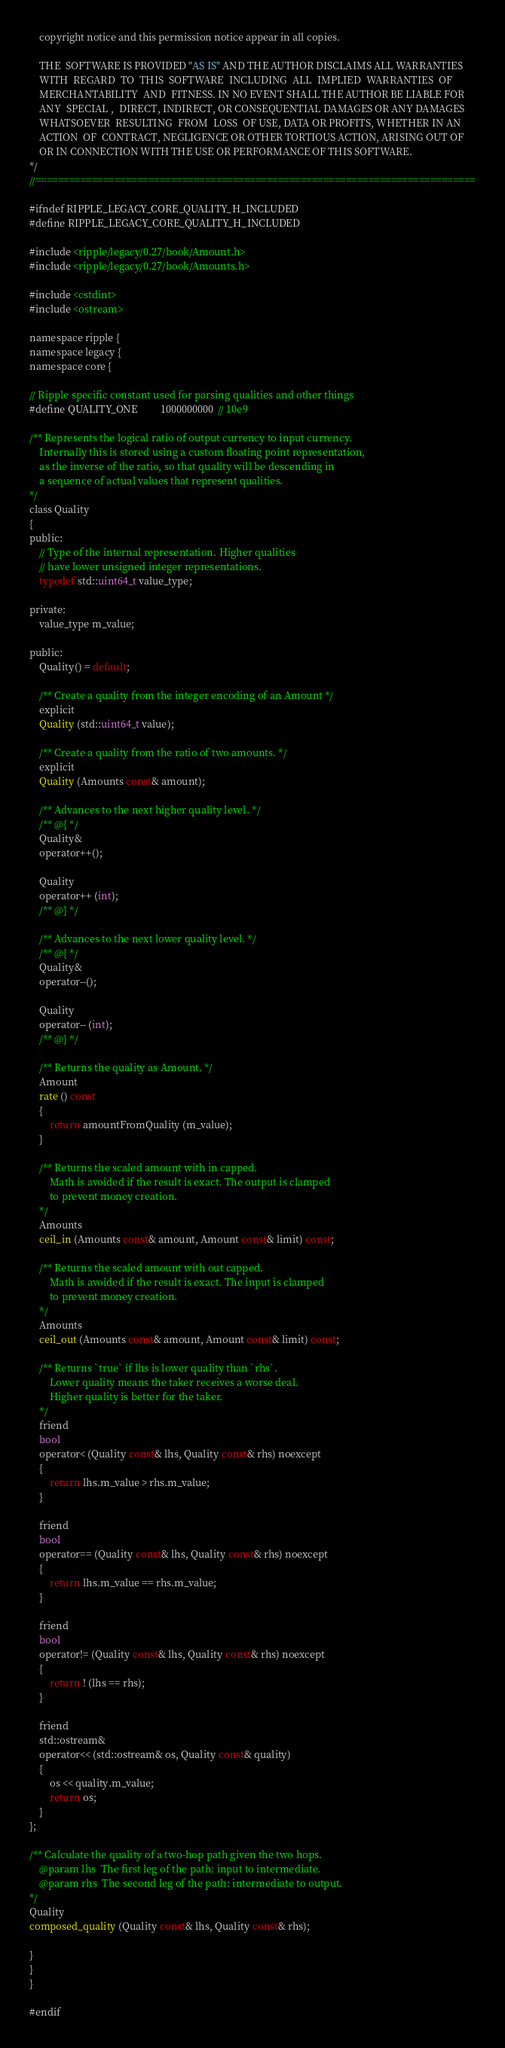Convert code to text. <code><loc_0><loc_0><loc_500><loc_500><_C_>    copyright notice and this permission notice appear in all copies.

    THE  SOFTWARE IS PROVIDED "AS IS" AND THE AUTHOR DISCLAIMS ALL WARRANTIES
    WITH  REGARD  TO  THIS  SOFTWARE  INCLUDING  ALL  IMPLIED  WARRANTIES  OF
    MERCHANTABILITY  AND  FITNESS. IN NO EVENT SHALL THE AUTHOR BE LIABLE FOR
    ANY  SPECIAL ,  DIRECT, INDIRECT, OR CONSEQUENTIAL DAMAGES OR ANY DAMAGES
    WHATSOEVER  RESULTING  FROM  LOSS  OF USE, DATA OR PROFITS, WHETHER IN AN
    ACTION  OF  CONTRACT, NEGLIGENCE OR OTHER TORTIOUS ACTION, ARISING OUT OF
    OR IN CONNECTION WITH THE USE OR PERFORMANCE OF THIS SOFTWARE.
*/
//==============================================================================

#ifndef RIPPLE_LEGACY_CORE_QUALITY_H_INCLUDED
#define RIPPLE_LEGACY_CORE_QUALITY_H_INCLUDED

#include <ripple/legacy/0.27/book/Amount.h>
#include <ripple/legacy/0.27/book/Amounts.h>

#include <cstdint>
#include <ostream>

namespace ripple {
namespace legacy {
namespace core {

// Ripple specific constant used for parsing qualities and other things
#define QUALITY_ONE         1000000000  // 10e9

/** Represents the logical ratio of output currency to input currency.
    Internally this is stored using a custom floating point representation,
    as the inverse of the ratio, so that quality will be descending in
    a sequence of actual values that represent qualities.
*/
class Quality
{
public:
    // Type of the internal representation. Higher qualities
    // have lower unsigned integer representations.
    typedef std::uint64_t value_type;

private:
    value_type m_value;

public:
    Quality() = default;

    /** Create a quality from the integer encoding of an Amount */
    explicit
    Quality (std::uint64_t value);

    /** Create a quality from the ratio of two amounts. */
    explicit
    Quality (Amounts const& amount);

    /** Advances to the next higher quality level. */
    /** @{ */
    Quality&
    operator++();

    Quality
    operator++ (int);
    /** @} */

    /** Advances to the next lower quality level. */
    /** @{ */
    Quality&
    operator--();

    Quality
    operator-- (int);
    /** @} */

    /** Returns the quality as Amount. */
    Amount
    rate () const
    {
        return amountFromQuality (m_value);
    }

    /** Returns the scaled amount with in capped.
        Math is avoided if the result is exact. The output is clamped
        to prevent money creation.
    */
    Amounts
    ceil_in (Amounts const& amount, Amount const& limit) const;

    /** Returns the scaled amount with out capped.
        Math is avoided if the result is exact. The input is clamped
        to prevent money creation.
    */
    Amounts
    ceil_out (Amounts const& amount, Amount const& limit) const;

    /** Returns `true` if lhs is lower quality than `rhs`.
        Lower quality means the taker receives a worse deal.
        Higher quality is better for the taker.
    */
    friend
    bool
    operator< (Quality const& lhs, Quality const& rhs) noexcept
    {
        return lhs.m_value > rhs.m_value;
    }

    friend
    bool
    operator== (Quality const& lhs, Quality const& rhs) noexcept
    {
        return lhs.m_value == rhs.m_value;
    }

    friend
    bool
    operator!= (Quality const& lhs, Quality const& rhs) noexcept
    {
        return ! (lhs == rhs);
    }

    friend
    std::ostream&
    operator<< (std::ostream& os, Quality const& quality)
    {
        os << quality.m_value;
        return os;
    }
};

/** Calculate the quality of a two-hop path given the two hops.
    @param lhs  The first leg of the path: input to intermediate.
    @param rhs  The second leg of the path: intermediate to output.
*/
Quality
composed_quality (Quality const& lhs, Quality const& rhs);

}
}
}

#endif
</code> 